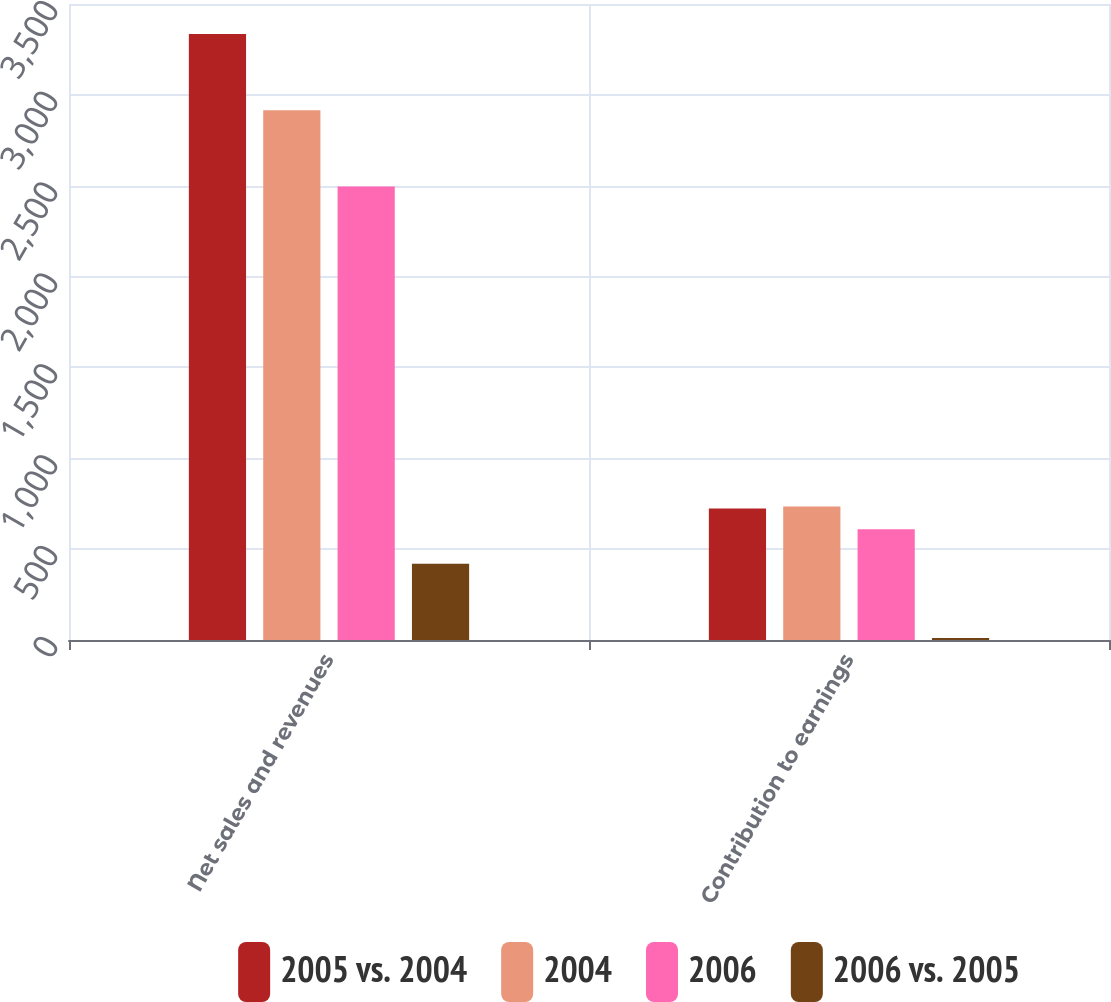<chart> <loc_0><loc_0><loc_500><loc_500><stacked_bar_chart><ecel><fcel>Net sales and revenues<fcel>Contribution to earnings<nl><fcel>2005 vs. 2004<fcel>3335<fcel>723<nl><fcel>2004<fcel>2915<fcel>734<nl><fcel>2006<fcel>2495<fcel>610<nl><fcel>2006 vs. 2005<fcel>420<fcel>11<nl></chart> 